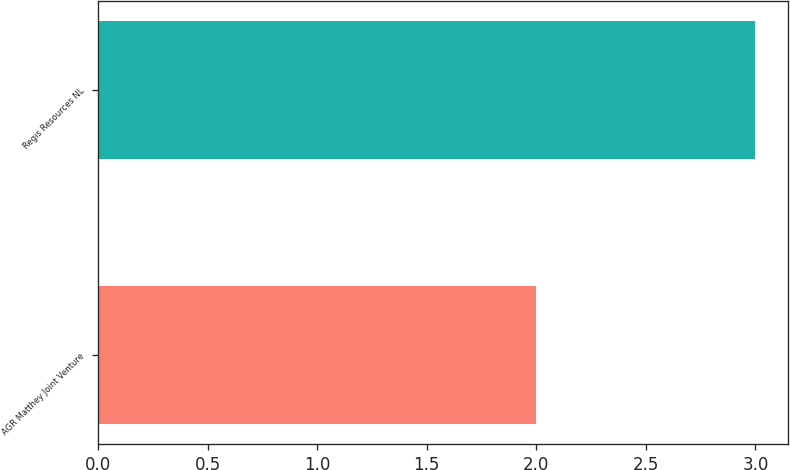Convert chart to OTSL. <chart><loc_0><loc_0><loc_500><loc_500><bar_chart><fcel>AGR Matthey Joint Venture<fcel>Regis Resources NL<nl><fcel>2<fcel>3<nl></chart> 